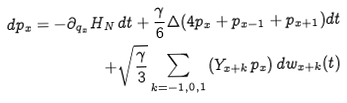<formula> <loc_0><loc_0><loc_500><loc_500>d p _ { x } = - \partial _ { q _ { x } } H _ { N } \, d t + \frac { \gamma } { 6 } \Delta ( 4 p _ { x } + p _ { x - 1 } + p _ { x + 1 } ) d t \\ + \sqrt { \frac { \gamma } { 3 } } \sum _ { k = - 1 , 0 , 1 } \left ( Y _ { x + k } p _ { x } \right ) d w _ { x + k } ( t )</formula> 